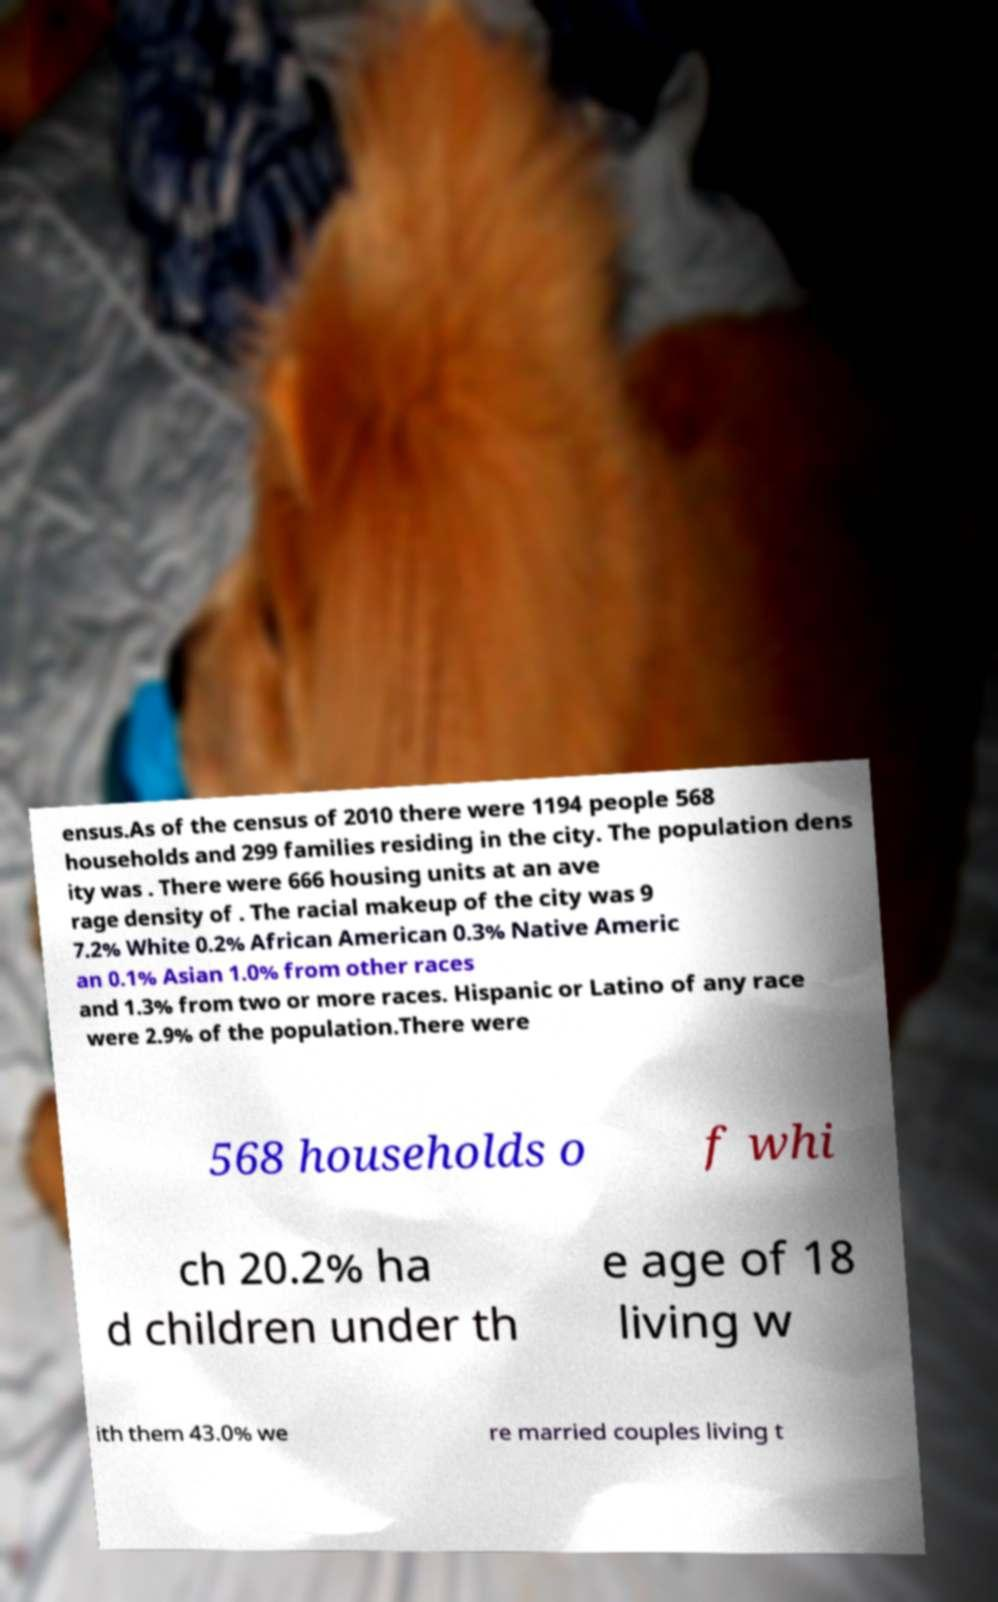For documentation purposes, I need the text within this image transcribed. Could you provide that? ensus.As of the census of 2010 there were 1194 people 568 households and 299 families residing in the city. The population dens ity was . There were 666 housing units at an ave rage density of . The racial makeup of the city was 9 7.2% White 0.2% African American 0.3% Native Americ an 0.1% Asian 1.0% from other races and 1.3% from two or more races. Hispanic or Latino of any race were 2.9% of the population.There were 568 households o f whi ch 20.2% ha d children under th e age of 18 living w ith them 43.0% we re married couples living t 